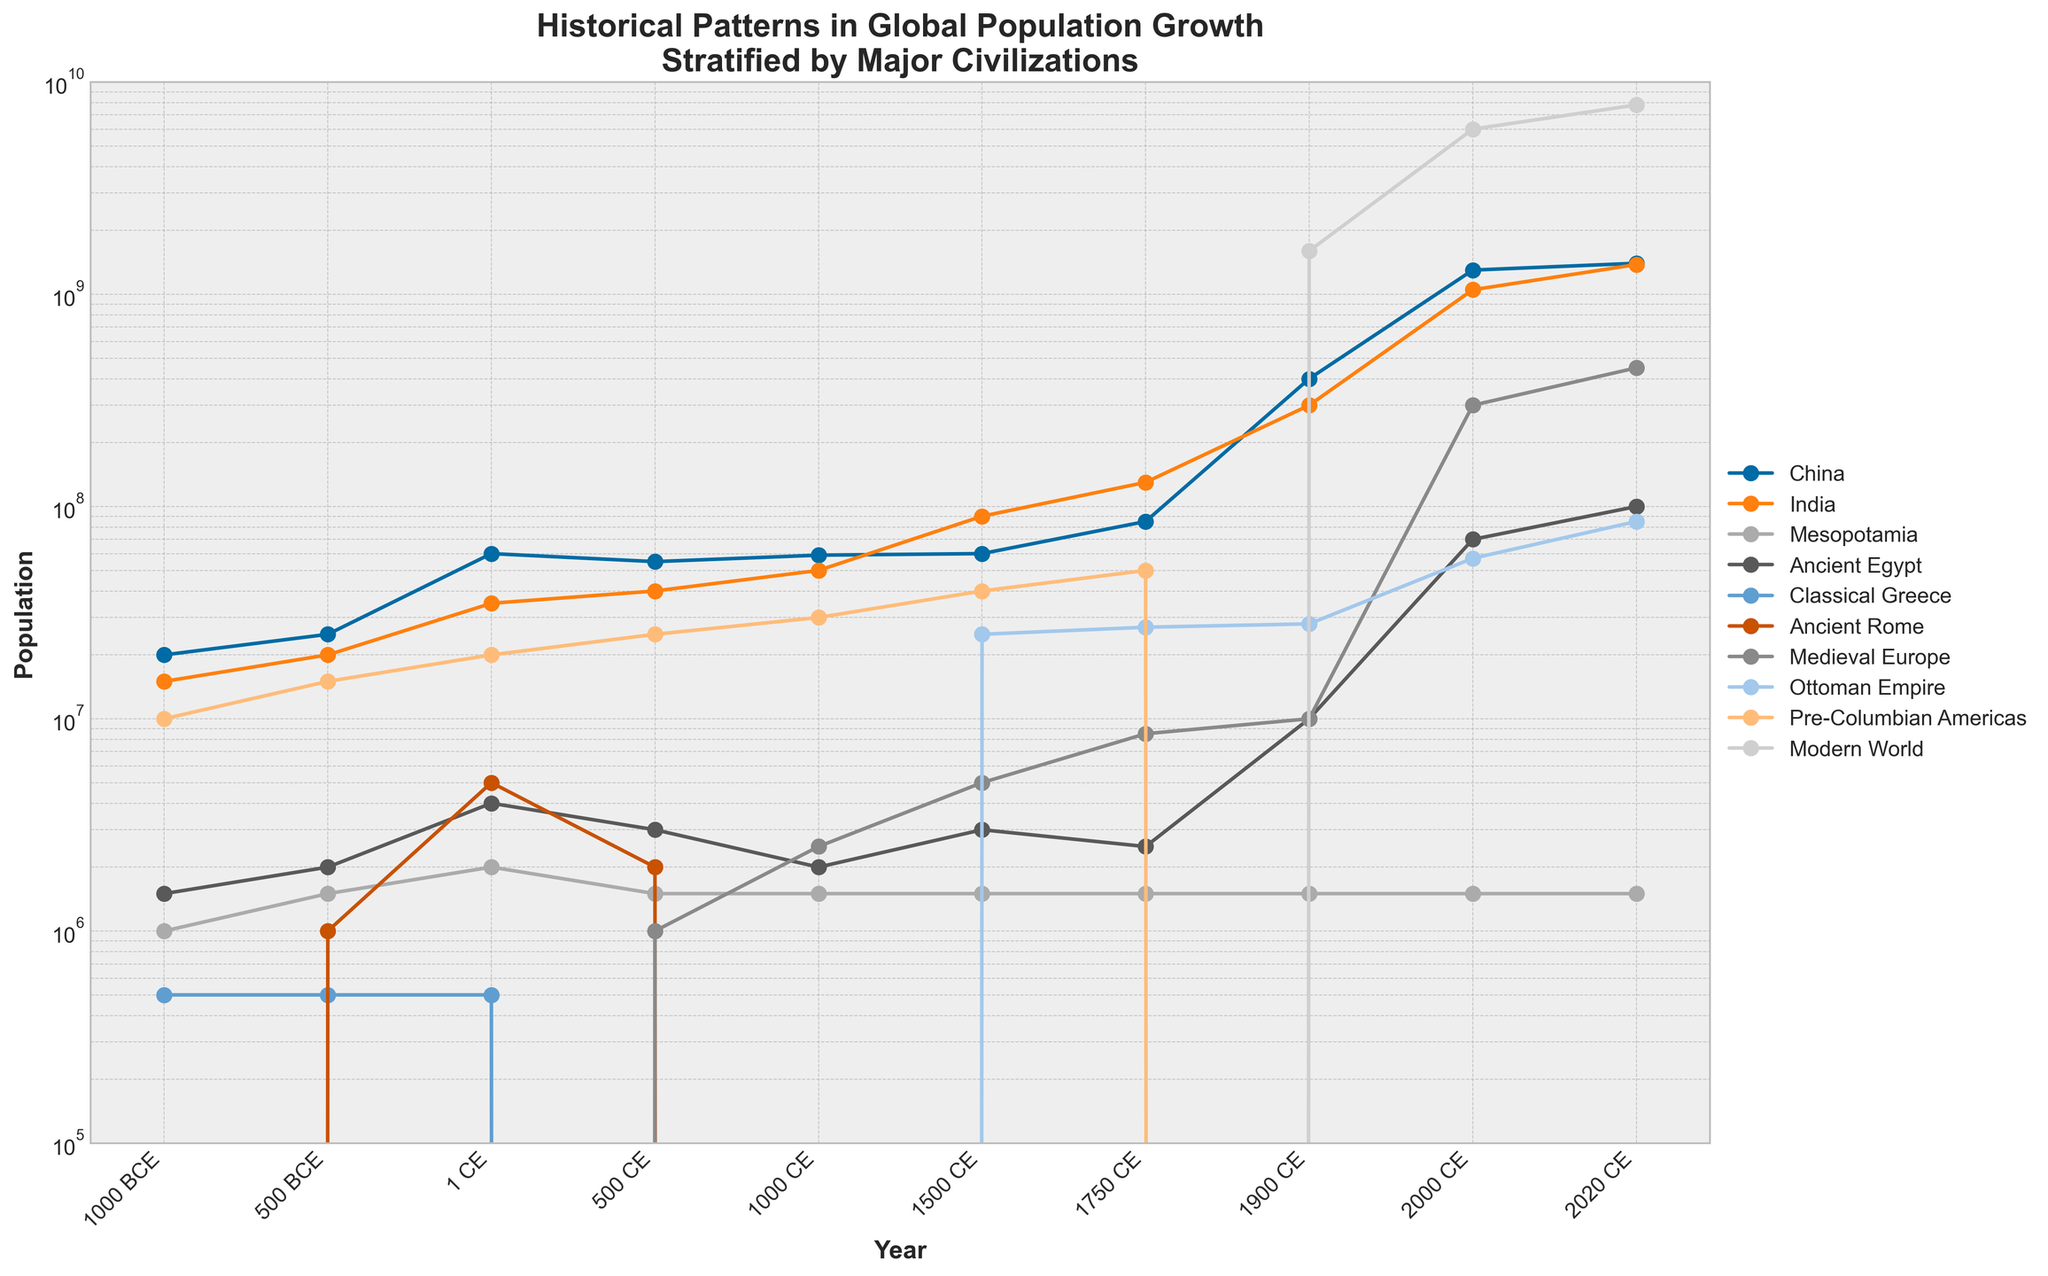What is the title of the figure? The title is displayed prominently at the top of the figure. It reads "Historical Patterns in Global Population Growth Stratified by Major Civilizations."
Answer: Historical Patterns in Global Population Growth Stratified by Major Civilizations Which civilization shows the highest population growth by 2020 CE? By observing the data points on the plot, the Modern World line reaches the highest point on the y-axis by 2020 CE.
Answer: Modern World What population does Ancient Egypt reach in 1 CE? Find the data point for Ancient Egypt at the year 1 CE; the plot shows a value of 4,000,000.
Answer: 4,000,000 Which two civilizations had populations close to each other around 1750 CE? At 1750 CE, compare the y-axis values of different civilizations. India and China have populations close to each other, with 130,000,000 and 85,000,000 respectively.
Answer: India and China When did the population of Pre-Columbian Americas reach 40,000,000? Check the data point on the Pre-Columbian Americas line that reaches 40,000,000; it occurs at 1500 CE.
Answer: 1500 CE How did the population of Medieval Europe compare to the Ottoman Empire in 1500 CE? For 1500 CE, compare the y-values of Medieval Europe and the Ottoman Empire. Medieval Europe has 5,000,000, while the Ottoman Empire has 25,000,000.
Answer: The Ottoman Empire was significantly larger What is the general trend in the population of China from 1000 BCE to 2020 CE? By observing the trend line for China, it consistently increases from 20,000,000 in 1000 BCE to 1,400,000,000 in 2020 CE.
Answer: Consistently increasing Around which year did the population of India surpass that of China? By cross-referencing the trend lines, India's population surpasses China's between 1500 CE and 1750 CE but distinctly by 1750 CE.
Answer: Around 1750 CE Calculate the average population of Mesopotamia throughout the recorded years. Sum the population values for Mesopotamia across all years (1,000,000 + 1,500,000 + 2,000,000 + 1,500,000 + 1,500,000 + 1,500,000 + 1,500,000 + 1,500,000 + 1,500,000 + 1,500,000 = 14,000,000) and divide by the number of data points (10). 14,000,000 / 10 = 1,400,000
Answer: 1,400,000 Which civilization experienced the most significant population growth between 1900 CE and 2000 CE? Compare the difference in population values between 1900 CE and 2000 CE for all civilizations. The Modern World experiences the most significant growth, from 1,600,000,000 to 6,000,000,000, growing by 4,400,000,000.
Answer: Modern World 